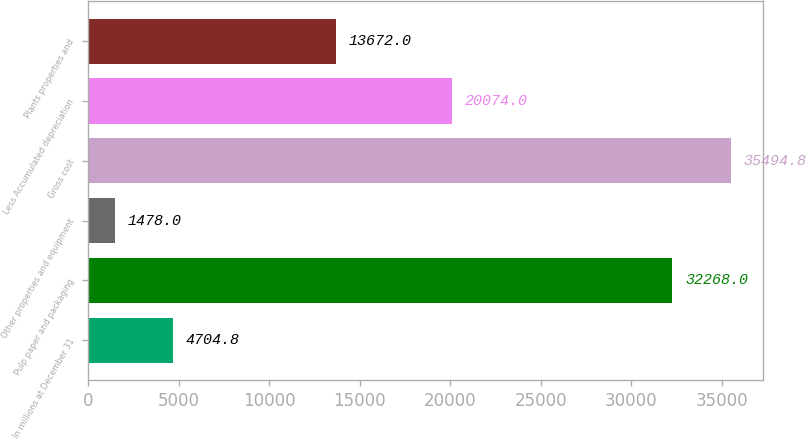Convert chart. <chart><loc_0><loc_0><loc_500><loc_500><bar_chart><fcel>In millions at December 31<fcel>Pulp paper and packaging<fcel>Other properties and equipment<fcel>Gross cost<fcel>Less Accumulated depreciation<fcel>Plants properties and<nl><fcel>4704.8<fcel>32268<fcel>1478<fcel>35494.8<fcel>20074<fcel>13672<nl></chart> 